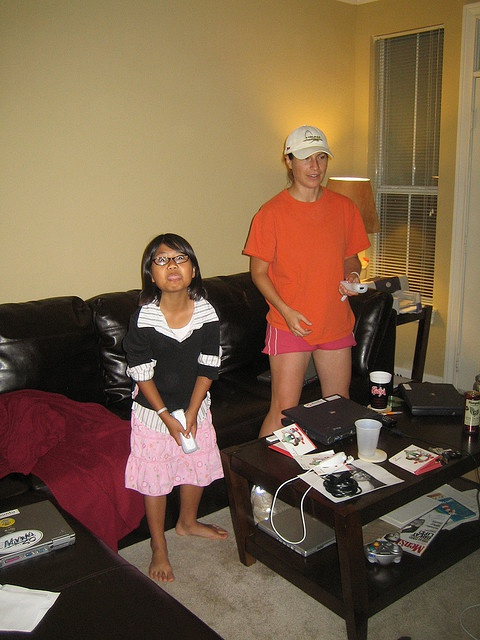Describe the objects in this image and their specific colors. I can see people in olive, black, lightgray, gray, and pink tones, people in olive, red, salmon, and brown tones, couch in olive, black, gray, and tan tones, couch in olive, maroon, black, brown, and purple tones, and laptop in olive, black, gray, and darkgray tones in this image. 